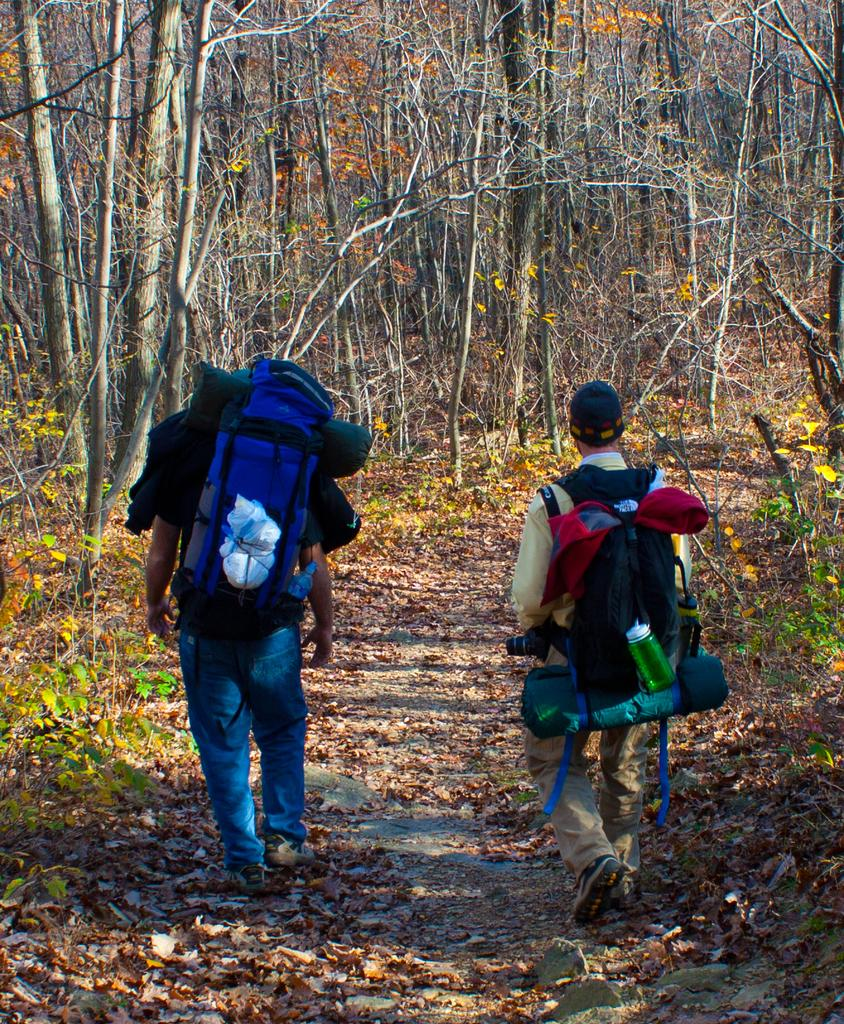How many people are in the image? There are two persons in the image. What are the persons doing in the image? The persons are carrying bags and walking on the ground. What is present on the ground in the image? Dried leaves are present on the ground. What else can be seen in the image besides the persons and the ground? There are bottles visible in the image. What can be seen in the background of the image? There are trees in the background of the image. What type of leather is being used to make the act of positioning the persons in the image? There is: There is no mention of leather or any act of positioning in the image; the persons are simply walking and carrying bags. 